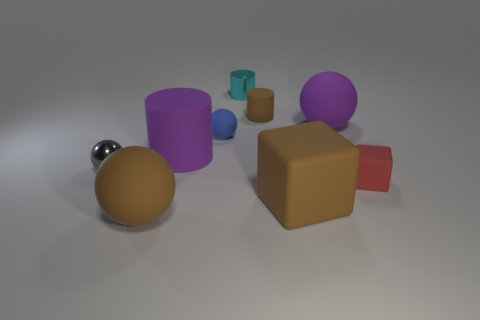What shades of colors are present in the objects displayed? The image showcases a variety of colors including purple, red, teal, blue, gold, silver, and brown tones.  Which object seems to be the largest, and which the smallest? The largest object appears to be the brown cube, while the smallest one seems to be a tiny teal cylinder. 